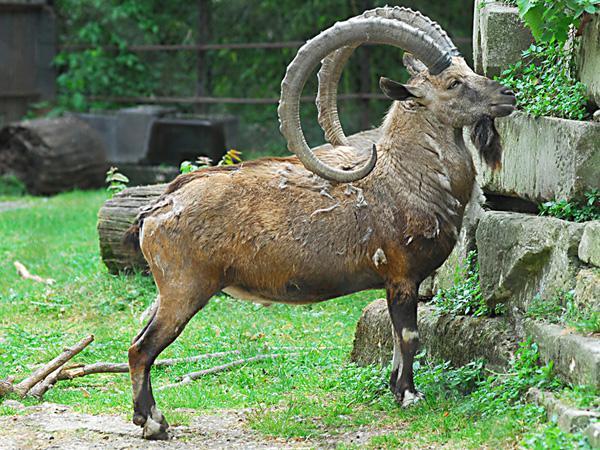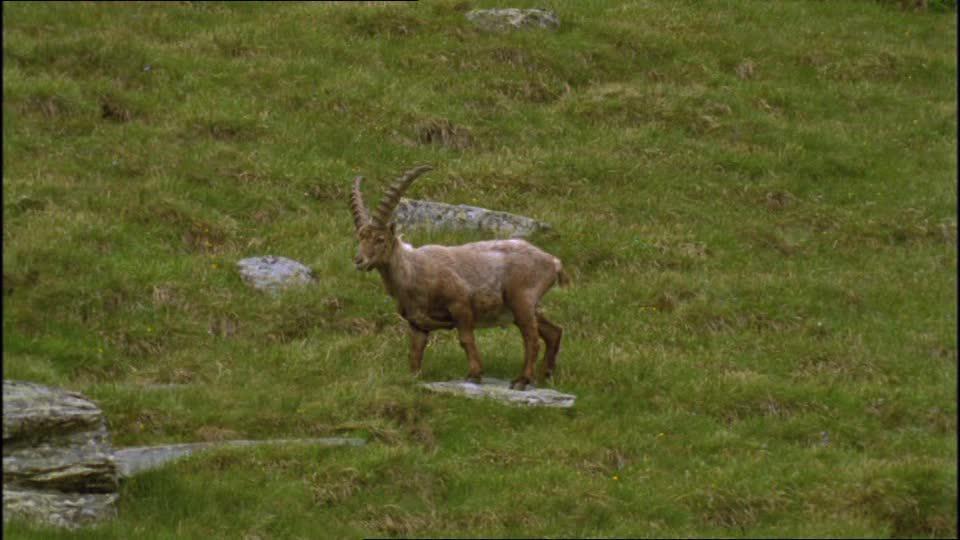The first image is the image on the left, the second image is the image on the right. Analyze the images presented: Is the assertion "An image shows one right-facing horned animal with moulting coat, standing in a green grassy area." valid? Answer yes or no. Yes. The first image is the image on the left, the second image is the image on the right. Given the left and right images, does the statement "There is a single horned animal in each of the images." hold true? Answer yes or no. Yes. 